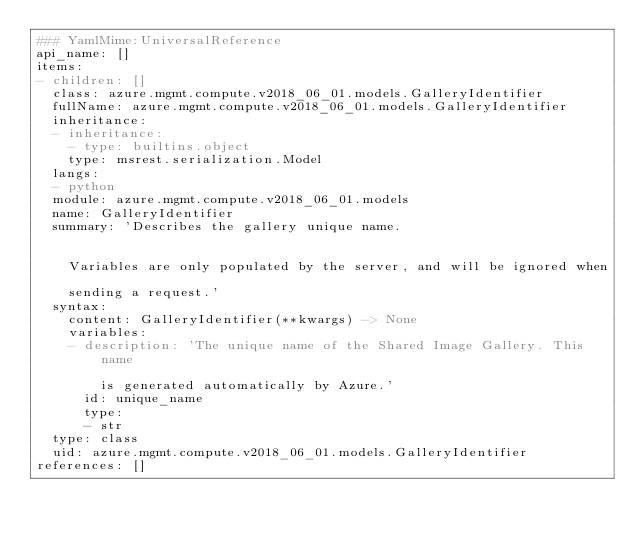Convert code to text. <code><loc_0><loc_0><loc_500><loc_500><_YAML_>### YamlMime:UniversalReference
api_name: []
items:
- children: []
  class: azure.mgmt.compute.v2018_06_01.models.GalleryIdentifier
  fullName: azure.mgmt.compute.v2018_06_01.models.GalleryIdentifier
  inheritance:
  - inheritance:
    - type: builtins.object
    type: msrest.serialization.Model
  langs:
  - python
  module: azure.mgmt.compute.v2018_06_01.models
  name: GalleryIdentifier
  summary: 'Describes the gallery unique name.


    Variables are only populated by the server, and will be ignored when

    sending a request.'
  syntax:
    content: GalleryIdentifier(**kwargs) -> None
    variables:
    - description: 'The unique name of the Shared Image Gallery. This name

        is generated automatically by Azure.'
      id: unique_name
      type:
      - str
  type: class
  uid: azure.mgmt.compute.v2018_06_01.models.GalleryIdentifier
references: []
</code> 